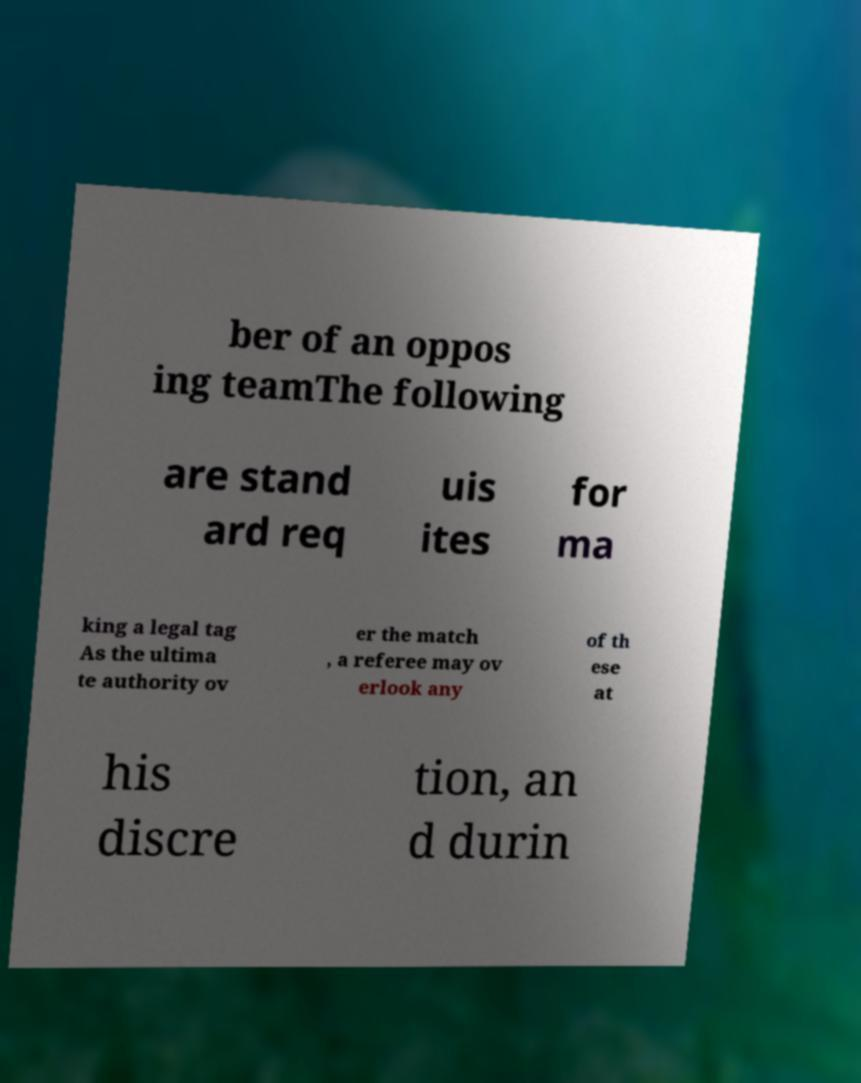Could you extract and type out the text from this image? ber of an oppos ing teamThe following are stand ard req uis ites for ma king a legal tag As the ultima te authority ov er the match , a referee may ov erlook any of th ese at his discre tion, an d durin 